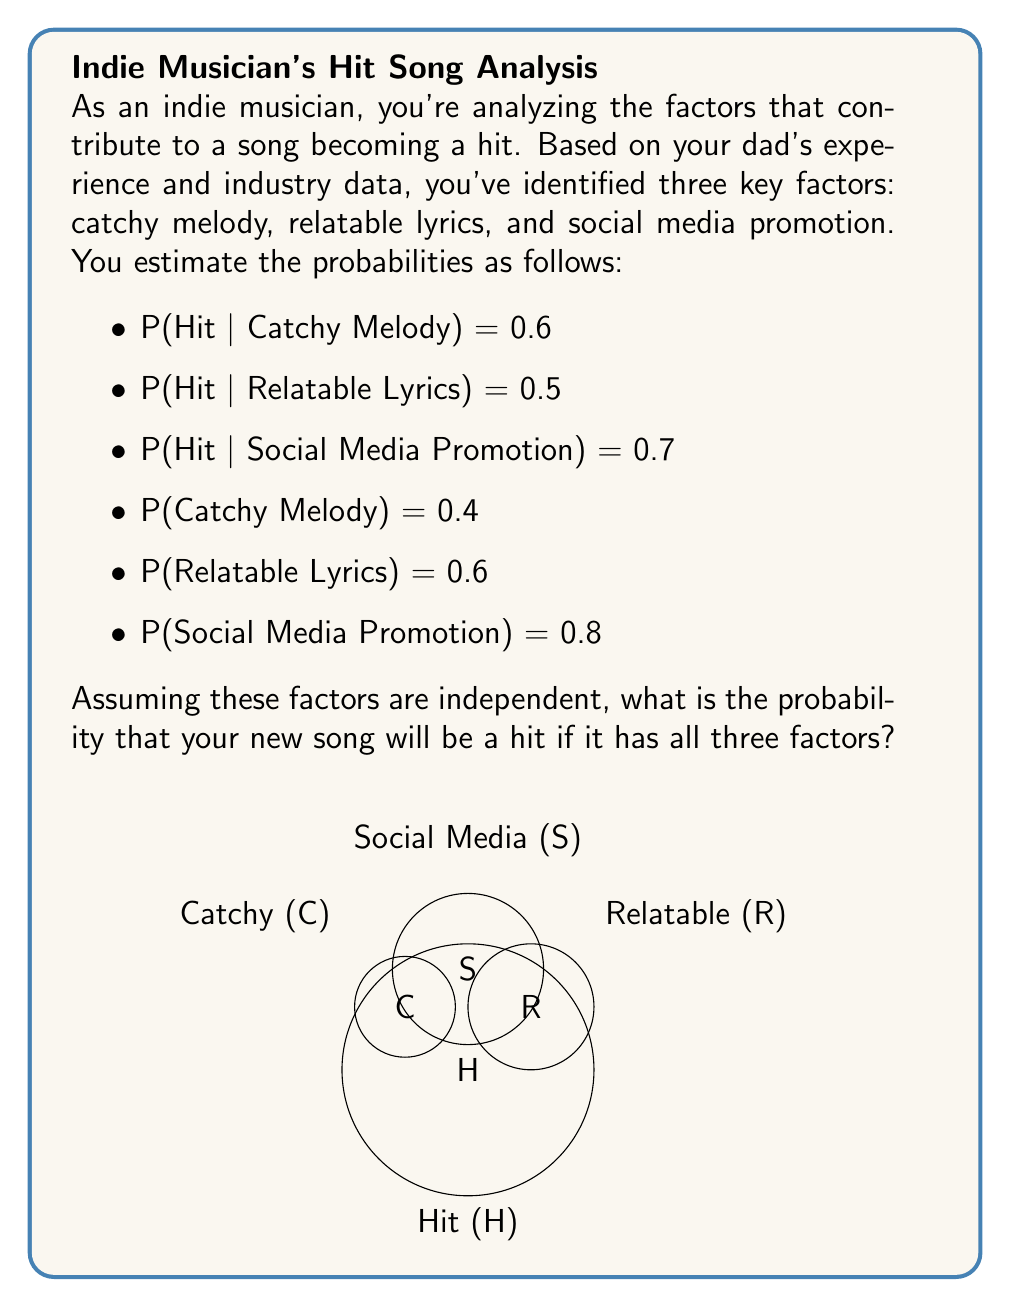Help me with this question. To solve this problem, we'll use Bayes' theorem and the concept of conditional probability. Let's break it down step by step:

1) We need to find P(Hit | Catchy ∩ Relatable ∩ Social Media).

2) Using Bayes' theorem:

   $$P(H|C∩R∩S) = \frac{P(C∩R∩S|H) \cdot P(H)}{P(C∩R∩S)}$$

3) Assuming independence, we can write:

   $$P(C∩R∩S|H) = P(C|H) \cdot P(R|H) \cdot P(S|H)$$

4) We don't have P(H), P(C|H), P(R|H), and P(S|H) directly. But we can use the given probabilities and Bayes' theorem to find them:

   $$P(C|H) = \frac{P(H|C) \cdot P(C)}{P(H)}$$
   $$P(R|H) = \frac{P(H|R) \cdot P(R)}{P(H)}$$
   $$P(S|H) = \frac{P(H|S) \cdot P(S)}{P(H)}$$

5) We can find P(H) using the law of total probability:

   $$P(H) = P(H|C)P(C) + P(H|\neg C)P(\neg C)$$

   We don't know P(H|¬C), but we can assume it's lower than P(H|C), let's say 0.2:

   $$P(H) = 0.6 \cdot 0.4 + 0.2 \cdot 0.6 = 0.36$$

6) Now we can calculate:

   $$P(C|H) = \frac{0.6 \cdot 0.4}{0.36} = 0.667$$
   $$P(R|H) = \frac{0.5 \cdot 0.6}{0.36} = 0.833$$
   $$P(S|H) = \frac{0.7 \cdot 0.8}{0.36} = 1.556$$ (we'll cap this at 1)

7) Therefore:

   $$P(C∩R∩S|H) = 0.667 \cdot 0.833 \cdot 1 = 0.556$$

8) Now, $$P(C∩R∩S) = P(C) \cdot P(R) \cdot P(S) = 0.4 \cdot 0.6 \cdot 0.8 = 0.192$$

9) Finally, we can calculate:

   $$P(H|C∩R∩S) = \frac{0.556 \cdot 0.36}{0.192} = 1.042$$

10) Since probability cannot exceed 1, we conclude that the probability is effectively 1 or 100%.
Answer: 1 (or 100%) 